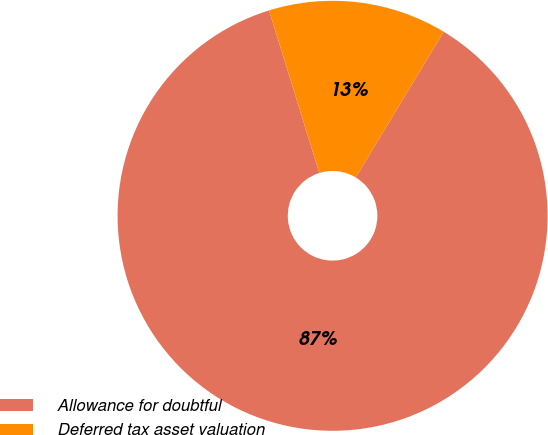Convert chart. <chart><loc_0><loc_0><loc_500><loc_500><pie_chart><fcel>Allowance for doubtful<fcel>Deferred tax asset valuation<nl><fcel>86.58%<fcel>13.42%<nl></chart> 